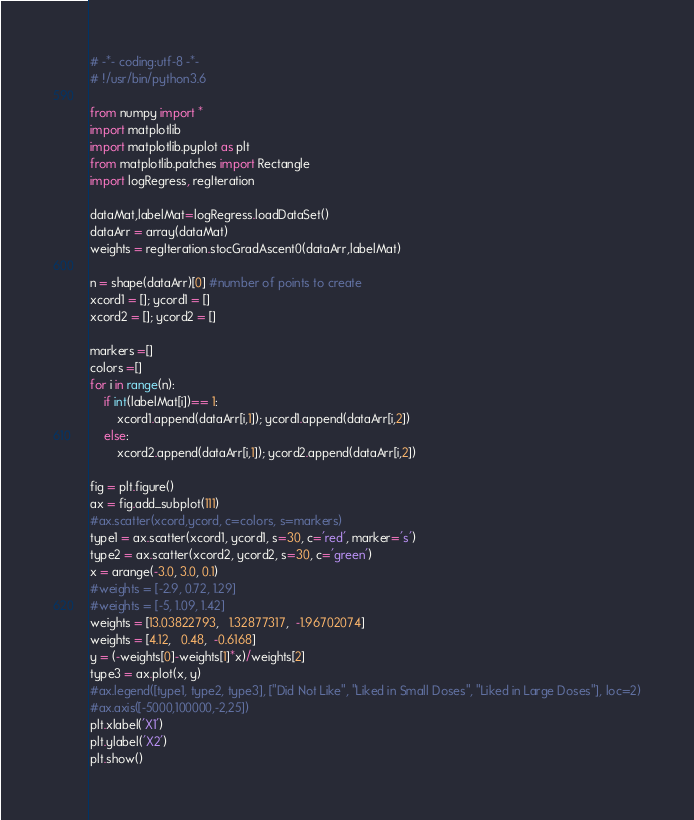<code> <loc_0><loc_0><loc_500><loc_500><_Python_># -*- coding:utf-8 -*-
# !/usr/bin/python3.6

from numpy import *
import matplotlib
import matplotlib.pyplot as plt
from matplotlib.patches import Rectangle
import logRegress, regIteration

dataMat,labelMat=logRegress.loadDataSet()
dataArr = array(dataMat)
weights = regIteration.stocGradAscent0(dataArr,labelMat)

n = shape(dataArr)[0] #number of points to create
xcord1 = []; ycord1 = []
xcord2 = []; ycord2 = []

markers =[]
colors =[]
for i in range(n):
    if int(labelMat[i])== 1:
        xcord1.append(dataArr[i,1]); ycord1.append(dataArr[i,2])
    else:
        xcord2.append(dataArr[i,1]); ycord2.append(dataArr[i,2])

fig = plt.figure()
ax = fig.add_subplot(111)
#ax.scatter(xcord,ycord, c=colors, s=markers)
type1 = ax.scatter(xcord1, ycord1, s=30, c='red', marker='s')
type2 = ax.scatter(xcord2, ycord2, s=30, c='green')
x = arange(-3.0, 3.0, 0.1)
#weights = [-2.9, 0.72, 1.29]
#weights = [-5, 1.09, 1.42]
weights = [13.03822793,   1.32877317,  -1.96702074]
weights = [4.12,   0.48,  -0.6168]
y = (-weights[0]-weights[1]*x)/weights[2]
type3 = ax.plot(x, y)
#ax.legend([type1, type2, type3], ["Did Not Like", "Liked in Small Doses", "Liked in Large Doses"], loc=2)
#ax.axis([-5000,100000,-2,25])
plt.xlabel('X1')
plt.ylabel('X2')
plt.show()</code> 